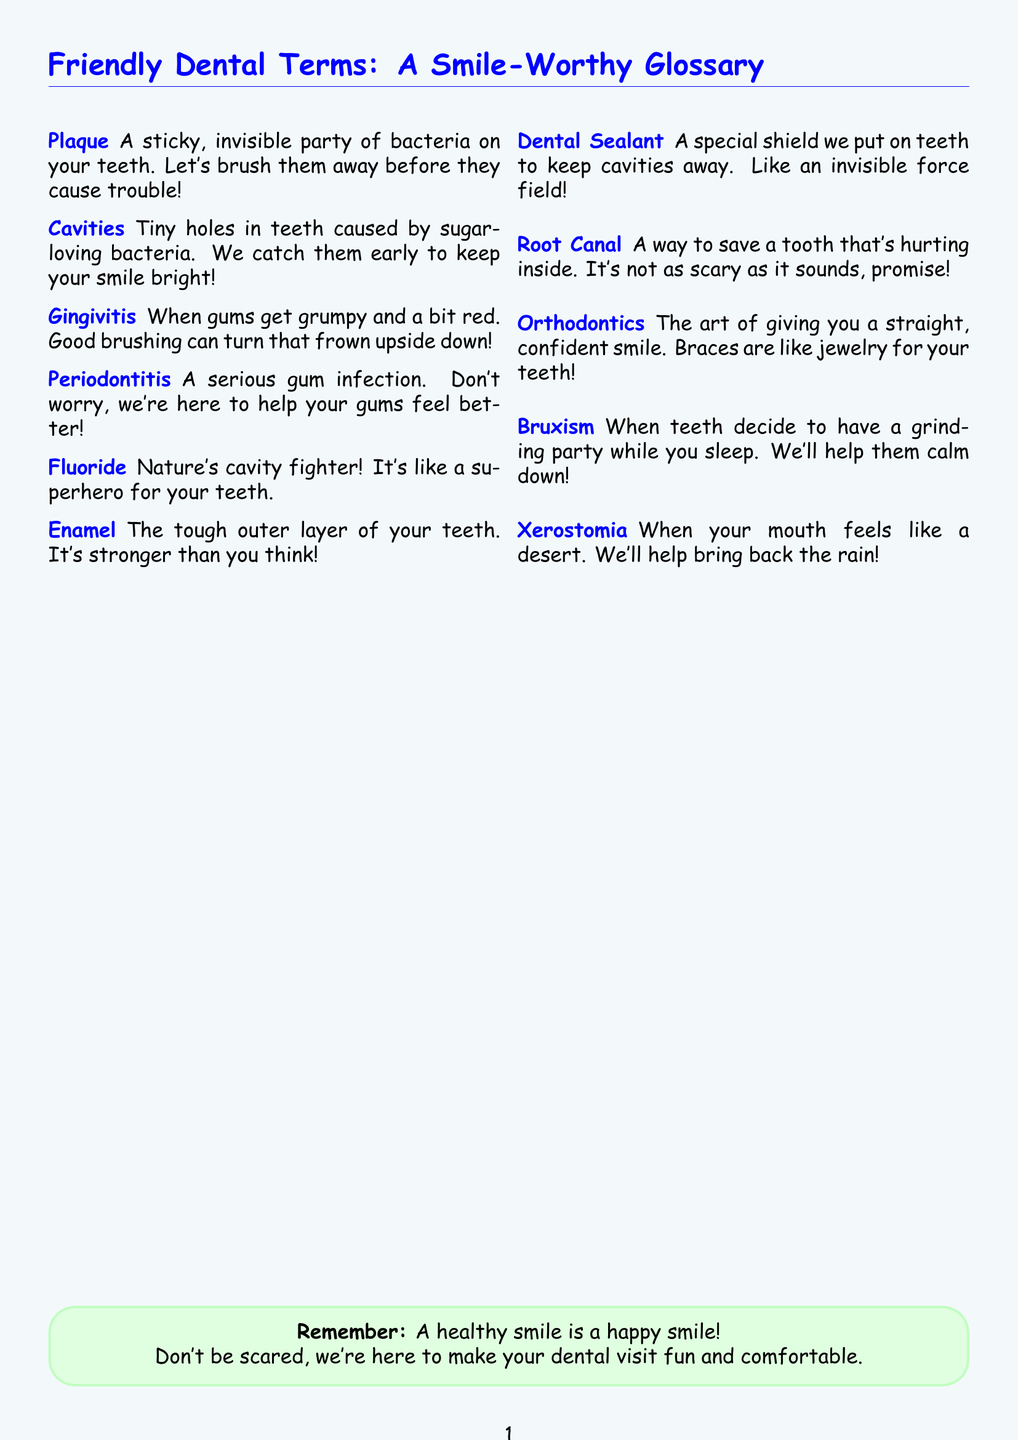What is the term for sticky bacteria on teeth? The term is defined as a "sticky, invisible party of bacteria on your teeth" in the document.
Answer: Plaque What are tiny holes in teeth called? The document states that they are "tiny holes in teeth caused by sugar-loving bacteria."
Answer: Cavities What is Gingivitis? It is described as "when gums get grumpy and a bit red."
Answer: When gums get grumpy What does Fluoride do? Fluoride is referred to as "Nature's cavity fighter" in the glossary, highlighting its protective role.
Answer: Cavity fighter What procedure is meant to save a hurting tooth? The document specifies that it is a "way to save a tooth that's hurting inside."
Answer: Root Canal What do braces belong to in dental terminology? The document categorizes braces under "the art of giving you a straight, confident smile."
Answer: Orthodontics What term is used for a mouth that feels dry? It is identified in the document as "when your mouth feels like a desert."
Answer: Xerostomia What protective measure is described as an "invisible force field"? This refers to a special measure mentioned in the document to keep cavities away.
Answer: Dental Sealant How many key terms are listed in the glossary? The document lists a total of 10 terms.
Answer: 10 